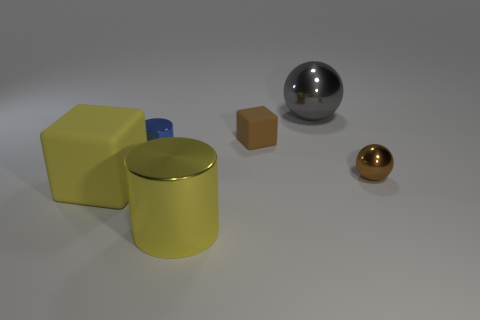Add 3 brown metal objects. How many objects exist? 9 Subtract all blocks. How many objects are left? 4 Subtract 0 green cylinders. How many objects are left? 6 Subtract all yellow cylinders. Subtract all small gray cubes. How many objects are left? 5 Add 4 big yellow metal cylinders. How many big yellow metal cylinders are left? 5 Add 4 big yellow matte objects. How many big yellow matte objects exist? 5 